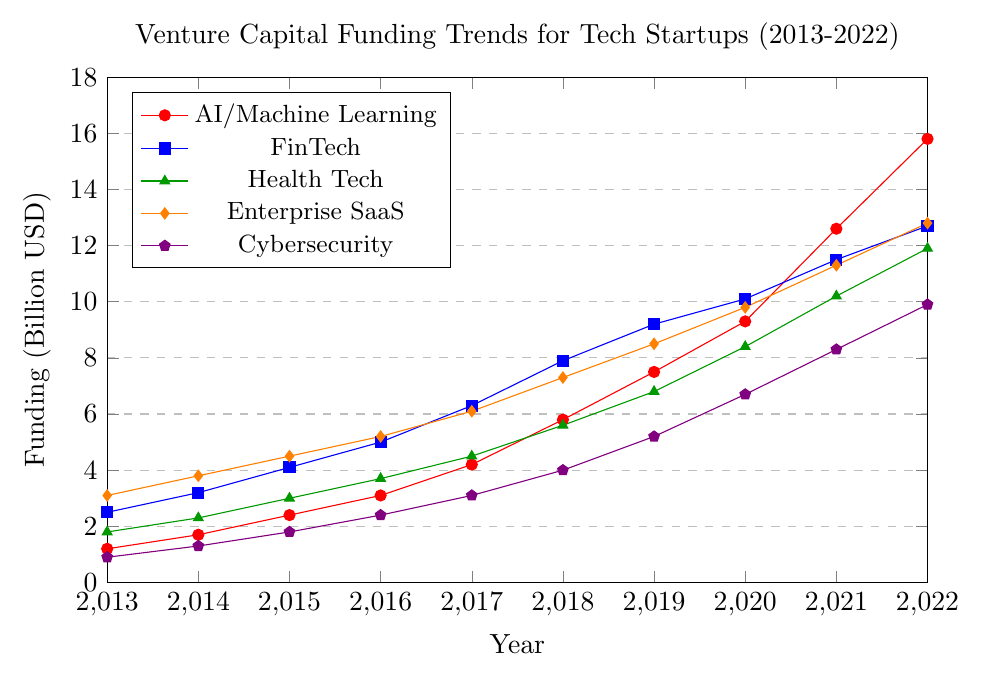What is the trend of Venture Capital (VC) funding for AI/Machine Learning from 2013 to 2022? The plot shows an increasing trend for AI/Machine Learning funding from 2013 to 2022. In 2013, it started at $1.2 billion and reached $15.8 billion by 2022.
Answer: Increasing Which industry had the highest VC funding in 2022? By observing the plot for the year 2022, the highest funding is given to AI/Machine Learning, which is represented by the red line reaching $15.8 billion.
Answer: AI/Machine Learning How does the VC funding for FinTech in 2015 compare to Health Tech in 2015? FinTech funding in 2015 is at $4.1 billion, while Health Tech funding in 2015 is at $3.0 billion. Therefore, FinTech had a higher value.
Answer: FinTech had higher funding What was the VC funding for Cybersecurity in 2017, and how much did it increase to by 2022? In 2017, Cybersecurity funding was $3.1 billion, and by 2022, it increased to $9.9 billion. The increase is calculated as $9.9 billion - $3.1 billion = $6.8 billion.
Answer: $6.8 billion Which two sectors had a similar increasing trend between 2019 and 2020, according to the visual? Both AI/Machine Learning and Health Tech had similar increasing trends between 2019 and 2020. AI/Machine Learning increased from $7.5 billion to $9.3 billion, and Health Tech increased from $6.8 billion to $8.4 billion.
Answer: AI/Machine Learning and Health Tech By how much did the Enterprise SaaS funding increase from 2014 to 2016? Enterprise SaaS funding was at $3.8 billion in 2014 and increased to $5.2 billion in 2016. The difference is calculated as $5.2 billion - $3.8 billion = $1.4 billion.
Answer: $1.4 billion What is the average annual VC funding for Health Tech from 2018 to 2022? The Health Tech funding for the years 2018 to 2022 are $5.6 billion, $6.8 billion, $8.4 billion, $10.2 billion, and $11.9 billion respectively. Summing these gives $42.9 billion. The average is $42.9 billion / 5 years = $8.58 billion.
Answer: $8.58 billion Did any sector have a consistent ranking in terms of total funding from 2013 to 2022? The sector with the most consistent ranking (highest) from 2013 to 2022 is FinTech, which also frequently resides at the top of the funding scale but lower than AI/Machine Learning evolving trend.
Answer: FinTech What is the funding difference between the highest and lowest funded sectors in 2020? The highest funded sector in 2020 is AI/Machine Learning at $9.8 billion, and the lowest is Cybersecurity at $6.7 billion. The difference is $9.8 billion - $6.7 billion = $3.1 billion.
Answer: $3.1 billion 